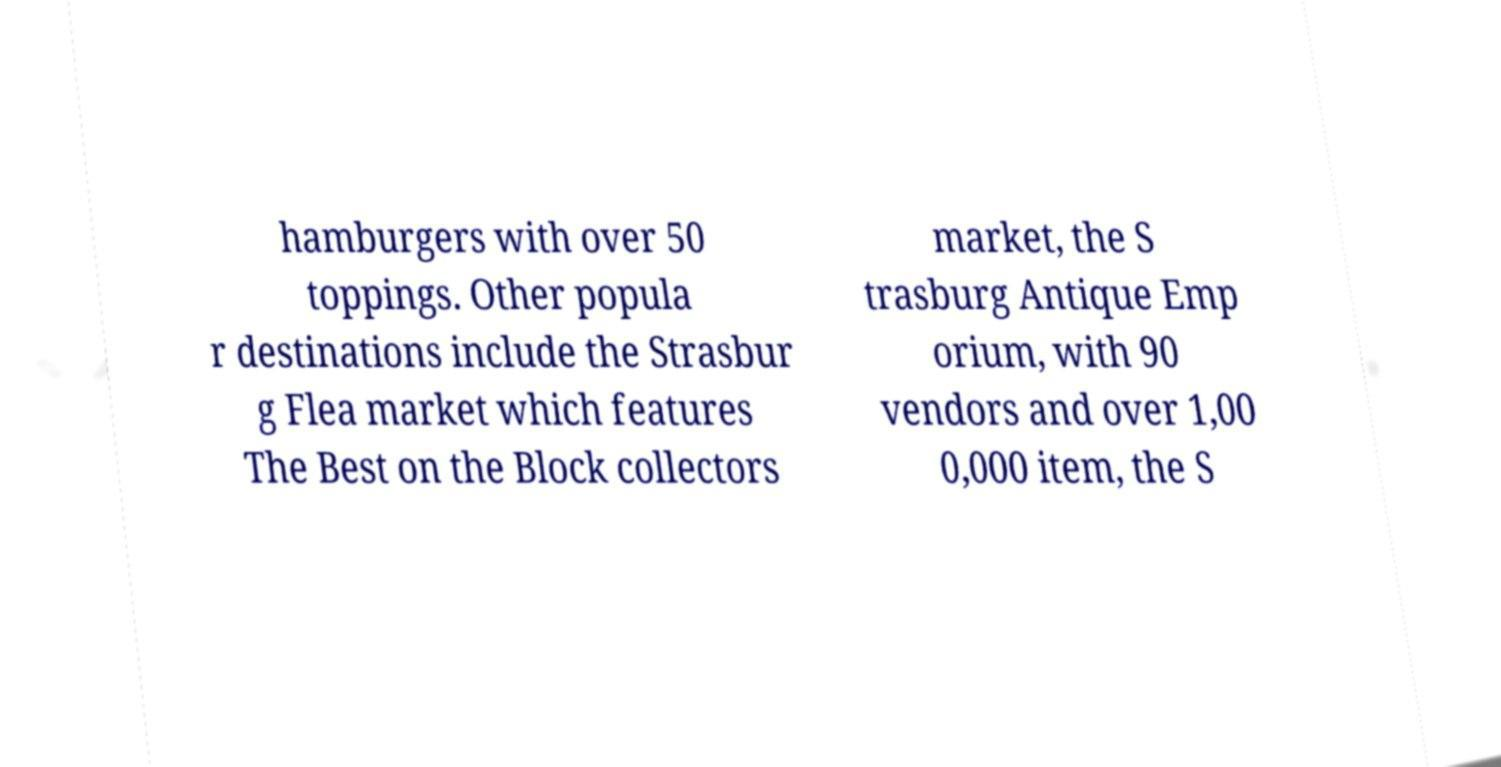There's text embedded in this image that I need extracted. Can you transcribe it verbatim? hamburgers with over 50 toppings. Other popula r destinations include the Strasbur g Flea market which features The Best on the Block collectors market, the S trasburg Antique Emp orium, with 90 vendors and over 1,00 0,000 item, the S 